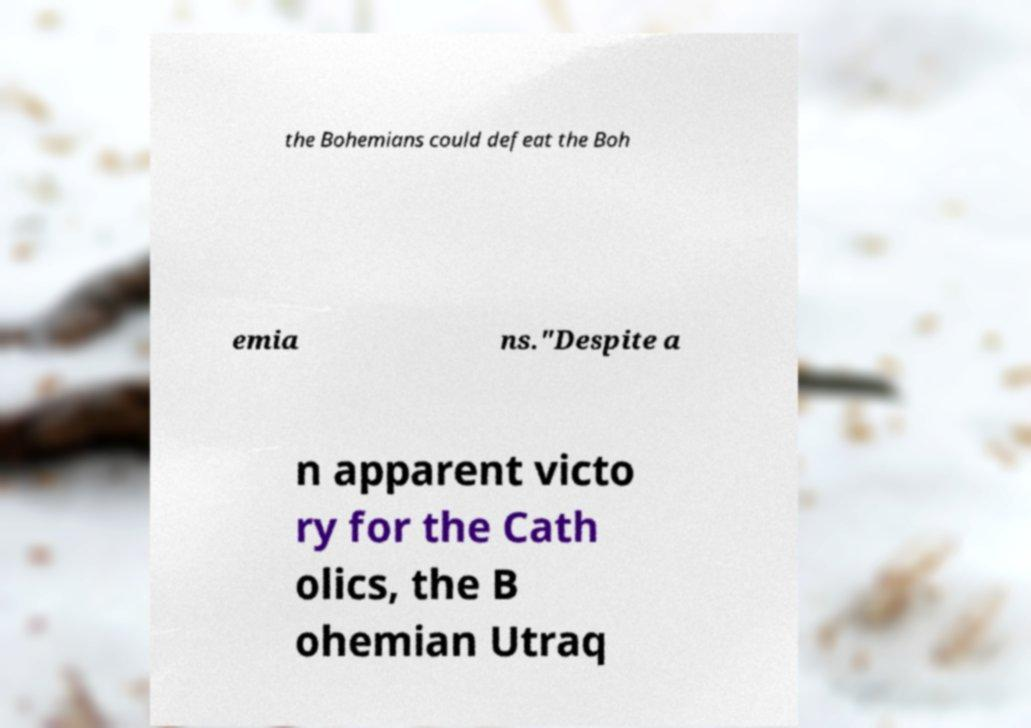Could you extract and type out the text from this image? the Bohemians could defeat the Boh emia ns."Despite a n apparent victo ry for the Cath olics, the B ohemian Utraq 